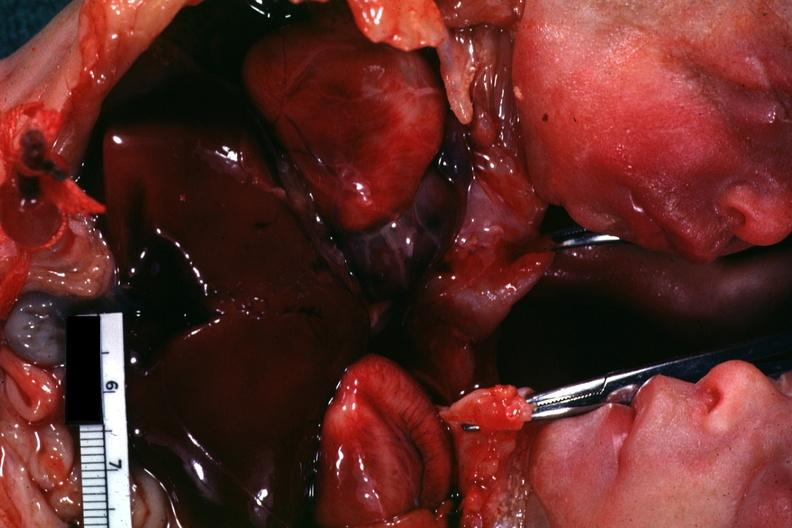what is present?
Answer the question using a single word or phrase. Siamese twins 